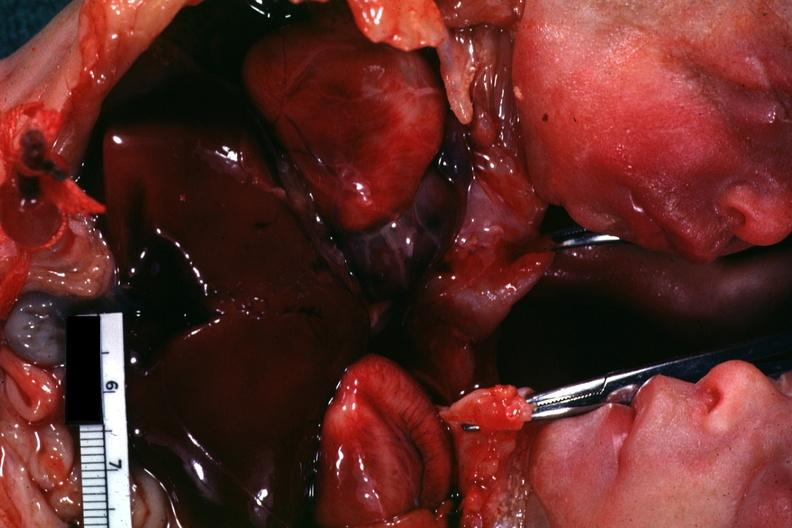what is present?
Answer the question using a single word or phrase. Siamese twins 